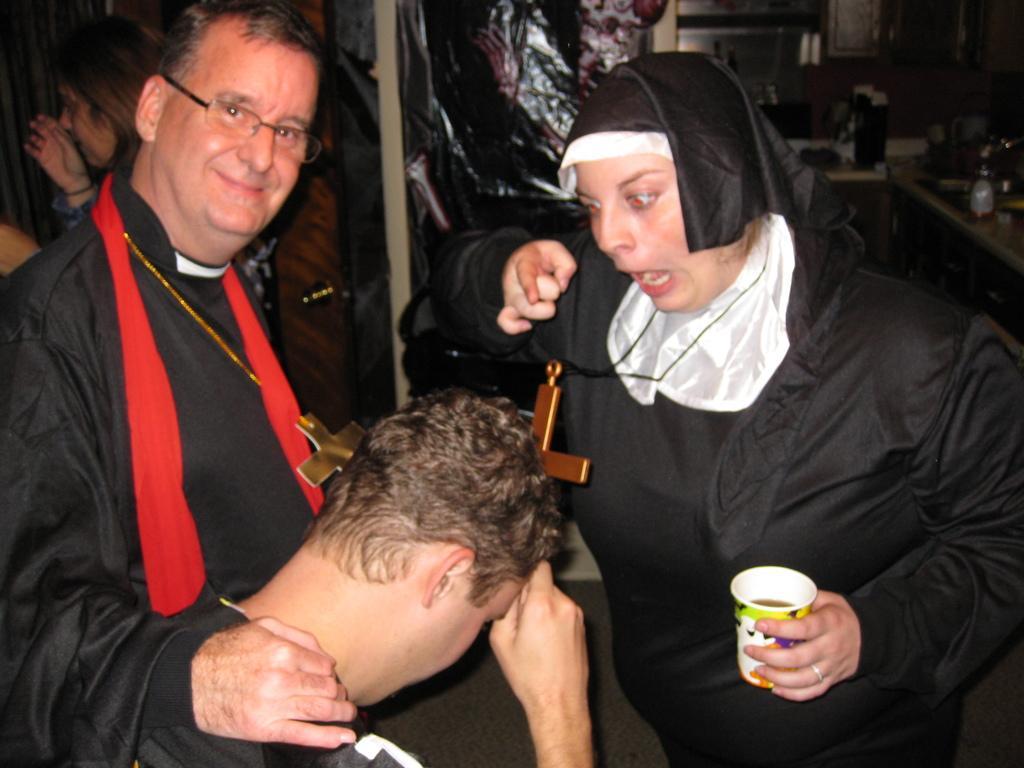How would you summarize this image in a sentence or two? In this image we can a group of people are standing. A lady is holding a glass in a hand at right most of the image. 